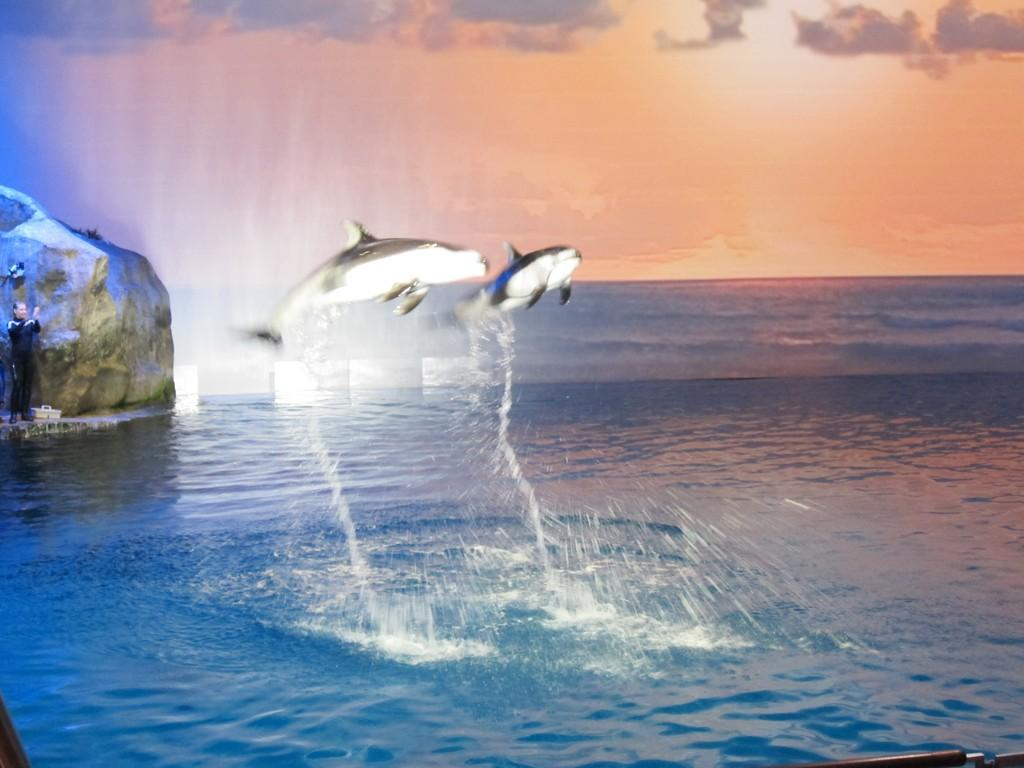What is present in the image? There is a person, water, stones, fishes, and the sky visible in the image. Can you describe the person in the image? The facts provided do not give any specific details about the person in the image. What is the water in the image situated on? The water is situated on stones in the image. What type of animals can be seen in the image? Fishes can be seen in the image. What is visible in the background of the image? The sky is visible in the background of the image. What type of wire is being used to protest in the image? There is no wire or protest present in the image. What type of soup is being served in the image? There is no soup present in the image. 